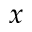<formula> <loc_0><loc_0><loc_500><loc_500>x</formula> 